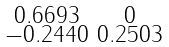<formula> <loc_0><loc_0><loc_500><loc_500>\begin{smallmatrix} 0 . 6 6 9 3 & 0 \\ - 0 . 2 4 4 0 & 0 . 2 5 0 3 \end{smallmatrix}</formula> 